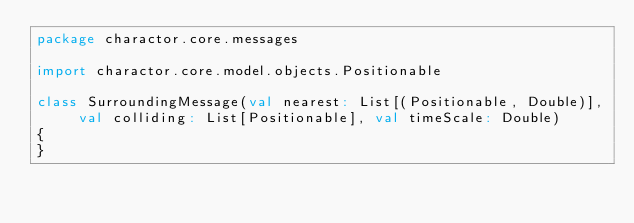Convert code to text. <code><loc_0><loc_0><loc_500><loc_500><_Scala_>package charactor.core.messages

import charactor.core.model.objects.Positionable

class SurroundingMessage(val nearest: List[(Positionable, Double)], val colliding: List[Positionable], val timeScale: Double)
{
}
</code> 